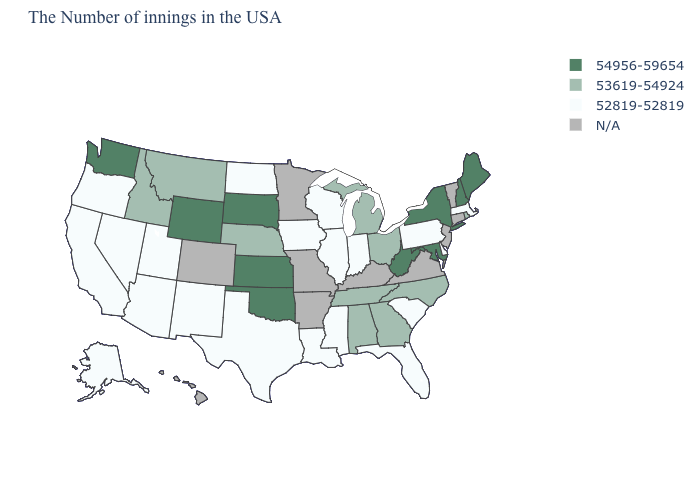Which states have the lowest value in the USA?
Short answer required. Massachusetts, Delaware, Pennsylvania, South Carolina, Florida, Indiana, Wisconsin, Illinois, Mississippi, Louisiana, Iowa, Texas, North Dakota, New Mexico, Utah, Arizona, Nevada, California, Oregon, Alaska. Name the states that have a value in the range 53619-54924?
Short answer required. Rhode Island, North Carolina, Ohio, Georgia, Michigan, Alabama, Tennessee, Nebraska, Montana, Idaho. Which states hav the highest value in the West?
Short answer required. Wyoming, Washington. What is the lowest value in the USA?
Short answer required. 52819-52819. What is the value of New Hampshire?
Be succinct. 54956-59654. Name the states that have a value in the range 52819-52819?
Answer briefly. Massachusetts, Delaware, Pennsylvania, South Carolina, Florida, Indiana, Wisconsin, Illinois, Mississippi, Louisiana, Iowa, Texas, North Dakota, New Mexico, Utah, Arizona, Nevada, California, Oregon, Alaska. Does the map have missing data?
Write a very short answer. Yes. Name the states that have a value in the range 53619-54924?
Short answer required. Rhode Island, North Carolina, Ohio, Georgia, Michigan, Alabama, Tennessee, Nebraska, Montana, Idaho. What is the highest value in states that border Alabama?
Give a very brief answer. 53619-54924. Does Massachusetts have the lowest value in the Northeast?
Give a very brief answer. Yes. Does North Dakota have the lowest value in the USA?
Write a very short answer. Yes. Among the states that border Wisconsin , does Iowa have the lowest value?
Keep it brief. Yes. Name the states that have a value in the range 52819-52819?
Give a very brief answer. Massachusetts, Delaware, Pennsylvania, South Carolina, Florida, Indiana, Wisconsin, Illinois, Mississippi, Louisiana, Iowa, Texas, North Dakota, New Mexico, Utah, Arizona, Nevada, California, Oregon, Alaska. What is the highest value in the Northeast ?
Write a very short answer. 54956-59654. Name the states that have a value in the range 54956-59654?
Short answer required. Maine, New Hampshire, New York, Maryland, West Virginia, Kansas, Oklahoma, South Dakota, Wyoming, Washington. 